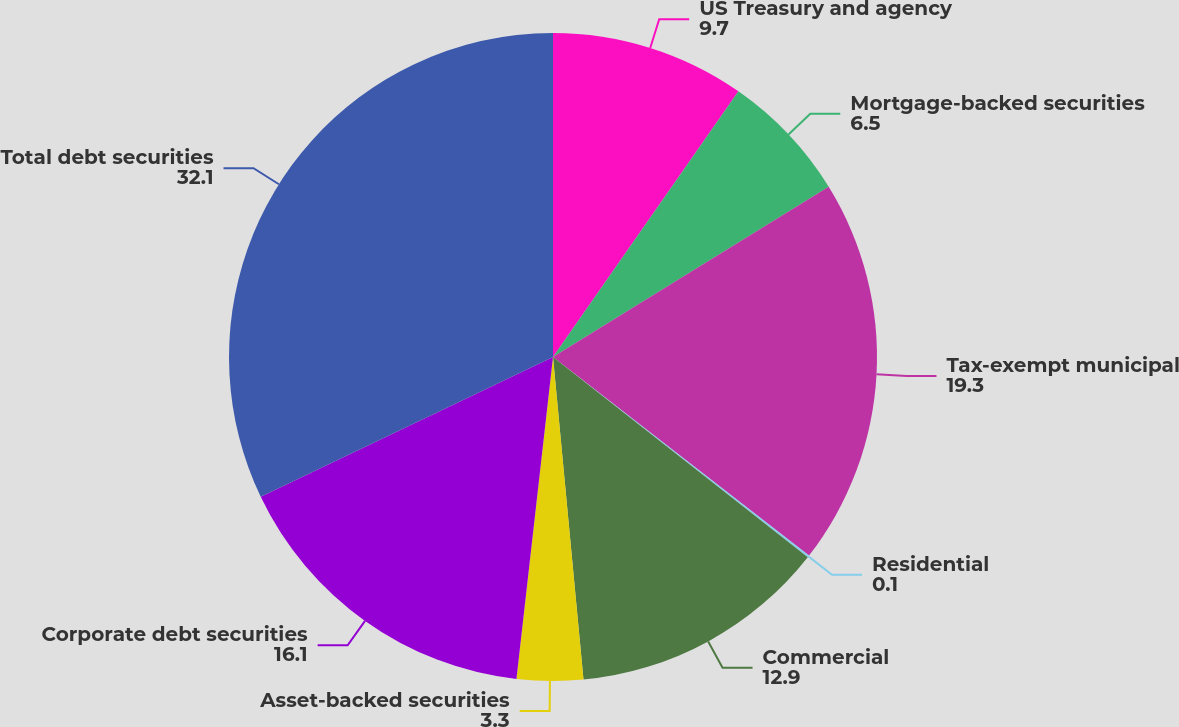<chart> <loc_0><loc_0><loc_500><loc_500><pie_chart><fcel>US Treasury and agency<fcel>Mortgage-backed securities<fcel>Tax-exempt municipal<fcel>Residential<fcel>Commercial<fcel>Asset-backed securities<fcel>Corporate debt securities<fcel>Total debt securities<nl><fcel>9.7%<fcel>6.5%<fcel>19.3%<fcel>0.1%<fcel>12.9%<fcel>3.3%<fcel>16.1%<fcel>32.1%<nl></chart> 